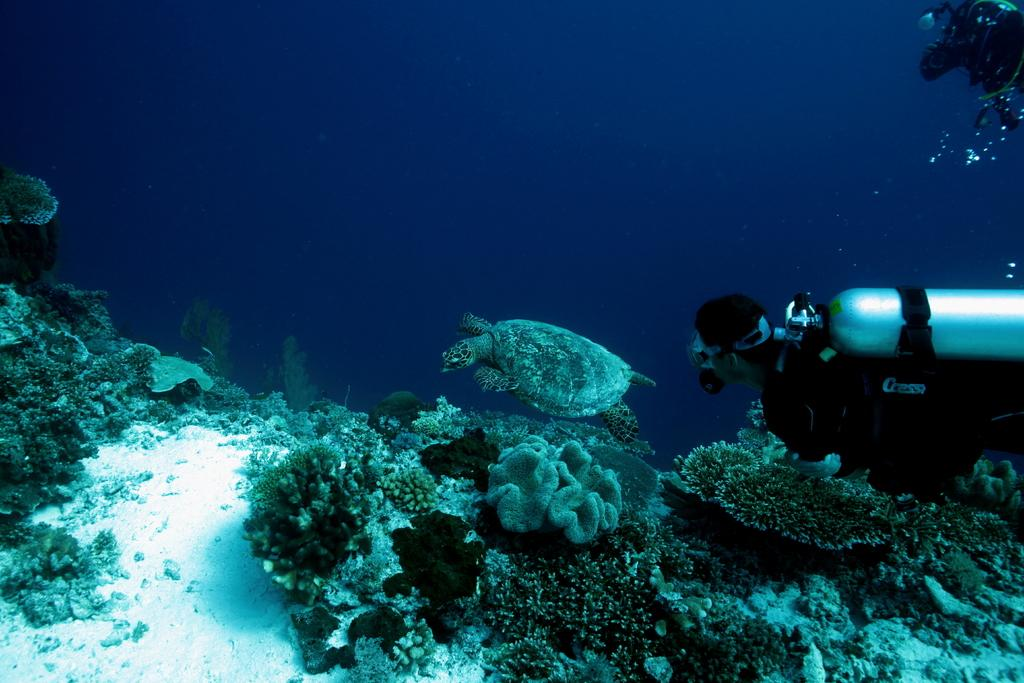What is the person in the image using? The person in the image is using an oxygen cylinder. What animal can be seen in the image? There is a turtle in the image. What type of underwater environment is visible in the image? There are reefs in the water in the image. How much peace does the authority have in the image? There is no reference to peace or authority in the image, as it features a person with an oxygen cylinder, a turtle, and reefs. 